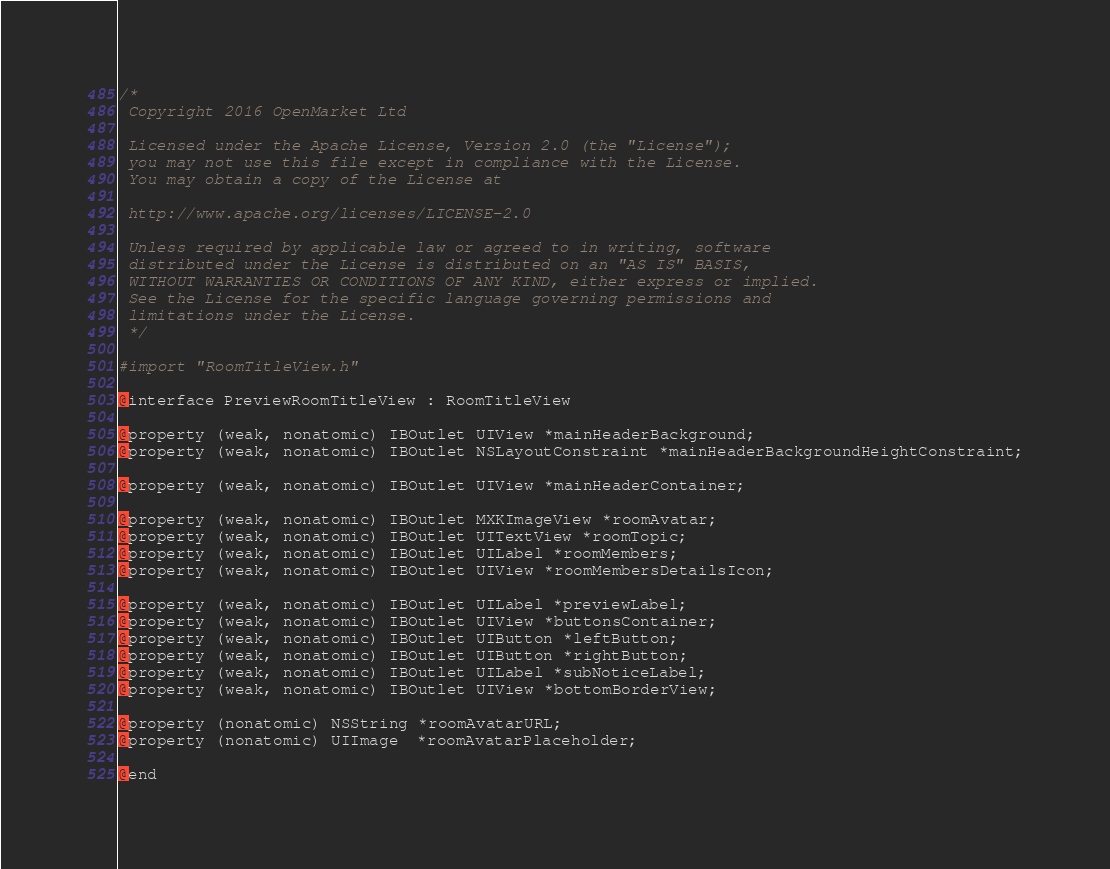<code> <loc_0><loc_0><loc_500><loc_500><_C_>/*
 Copyright 2016 OpenMarket Ltd
 
 Licensed under the Apache License, Version 2.0 (the "License");
 you may not use this file except in compliance with the License.
 You may obtain a copy of the License at
 
 http://www.apache.org/licenses/LICENSE-2.0
 
 Unless required by applicable law or agreed to in writing, software
 distributed under the License is distributed on an "AS IS" BASIS,
 WITHOUT WARRANTIES OR CONDITIONS OF ANY KIND, either express or implied.
 See the License for the specific language governing permissions and
 limitations under the License.
 */

#import "RoomTitleView.h"

@interface PreviewRoomTitleView : RoomTitleView

@property (weak, nonatomic) IBOutlet UIView *mainHeaderBackground;
@property (weak, nonatomic) IBOutlet NSLayoutConstraint *mainHeaderBackgroundHeightConstraint;

@property (weak, nonatomic) IBOutlet UIView *mainHeaderContainer;

@property (weak, nonatomic) IBOutlet MXKImageView *roomAvatar;
@property (weak, nonatomic) IBOutlet UITextView *roomTopic;
@property (weak, nonatomic) IBOutlet UILabel *roomMembers;
@property (weak, nonatomic) IBOutlet UIView *roomMembersDetailsIcon;

@property (weak, nonatomic) IBOutlet UILabel *previewLabel;
@property (weak, nonatomic) IBOutlet UIView *buttonsContainer;
@property (weak, nonatomic) IBOutlet UIButton *leftButton;
@property (weak, nonatomic) IBOutlet UIButton *rightButton;
@property (weak, nonatomic) IBOutlet UILabel *subNoticeLabel;
@property (weak, nonatomic) IBOutlet UIView *bottomBorderView;

@property (nonatomic) NSString *roomAvatarURL;
@property (nonatomic) UIImage  *roomAvatarPlaceholder;

@end
</code> 